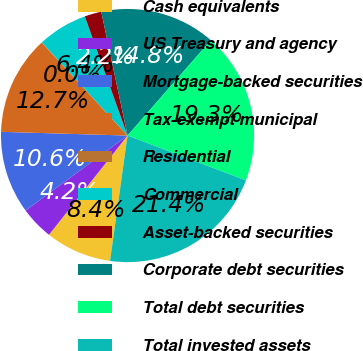Convert chart. <chart><loc_0><loc_0><loc_500><loc_500><pie_chart><fcel>Cash equivalents<fcel>US Treasury and agency<fcel>Mortgage-backed securities<fcel>Tax-exempt municipal<fcel>Residential<fcel>Commercial<fcel>Asset-backed securities<fcel>Corporate debt securities<fcel>Total debt securities<fcel>Total invested assets<nl><fcel>8.45%<fcel>4.25%<fcel>10.56%<fcel>12.66%<fcel>0.04%<fcel>6.35%<fcel>2.15%<fcel>14.76%<fcel>19.34%<fcel>21.44%<nl></chart> 